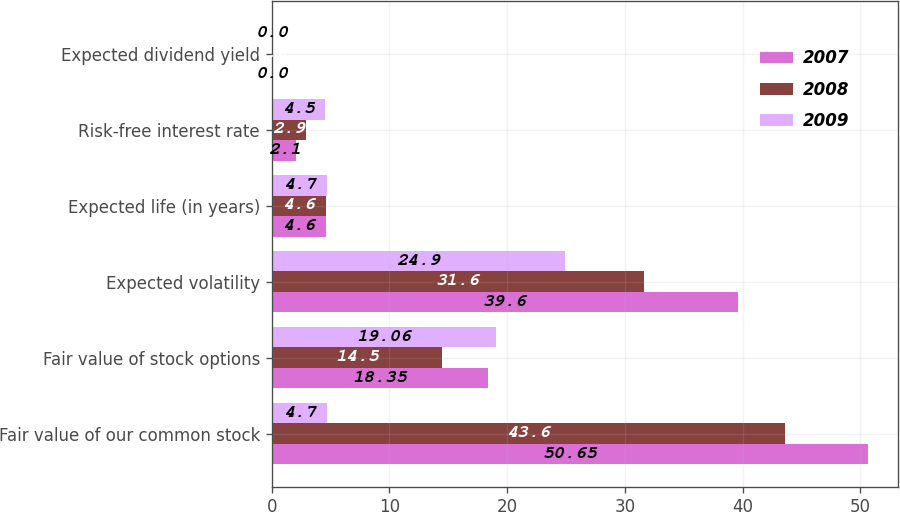Convert chart. <chart><loc_0><loc_0><loc_500><loc_500><stacked_bar_chart><ecel><fcel>Fair value of our common stock<fcel>Fair value of stock options<fcel>Expected volatility<fcel>Expected life (in years)<fcel>Risk-free interest rate<fcel>Expected dividend yield<nl><fcel>2007<fcel>50.65<fcel>18.35<fcel>39.6<fcel>4.6<fcel>2.1<fcel>0<nl><fcel>2008<fcel>43.6<fcel>14.5<fcel>31.6<fcel>4.6<fcel>2.9<fcel>0<nl><fcel>2009<fcel>4.7<fcel>19.06<fcel>24.9<fcel>4.7<fcel>4.5<fcel>0<nl></chart> 